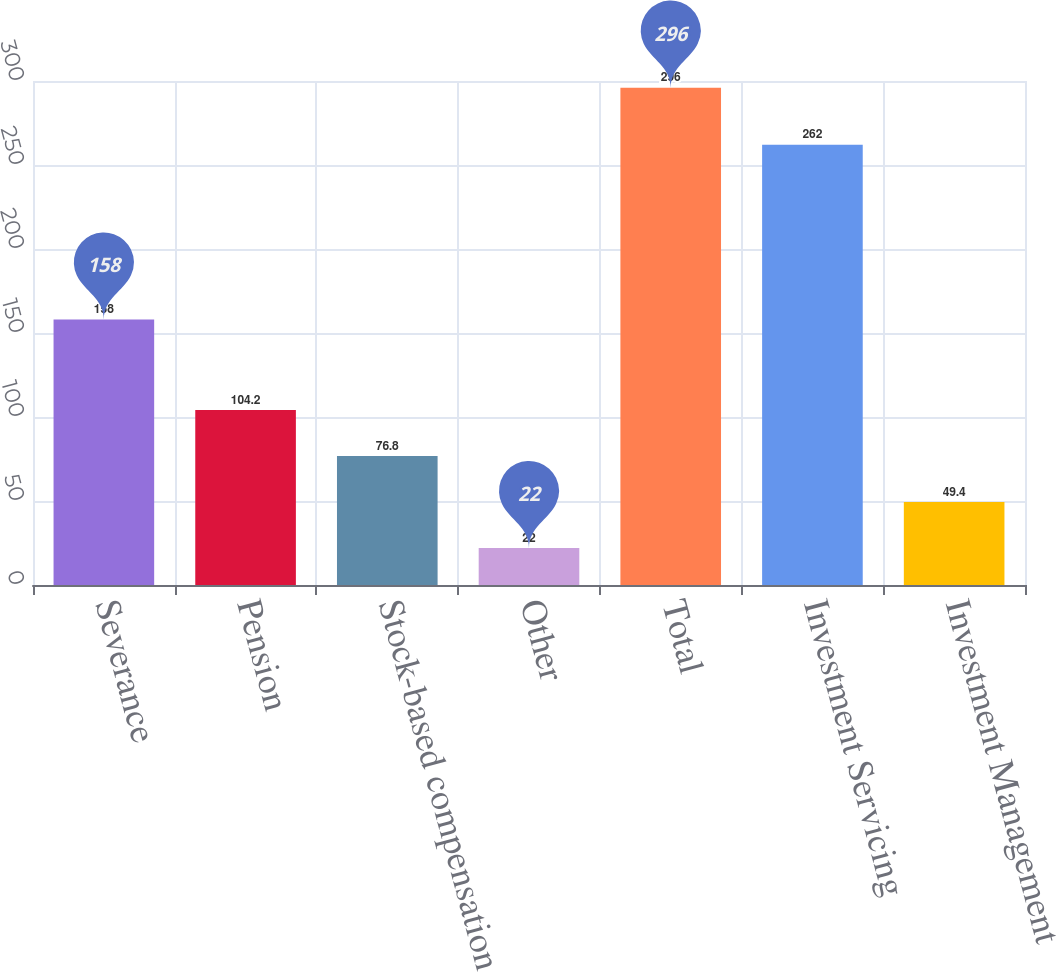Convert chart to OTSL. <chart><loc_0><loc_0><loc_500><loc_500><bar_chart><fcel>Severance<fcel>Pension<fcel>Stock-based compensation<fcel>Other<fcel>Total<fcel>Investment Servicing<fcel>Investment Management<nl><fcel>158<fcel>104.2<fcel>76.8<fcel>22<fcel>296<fcel>262<fcel>49.4<nl></chart> 